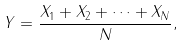<formula> <loc_0><loc_0><loc_500><loc_500>Y = \frac { X _ { 1 } + X _ { 2 } + \dots + X _ { N } } { N } ,</formula> 